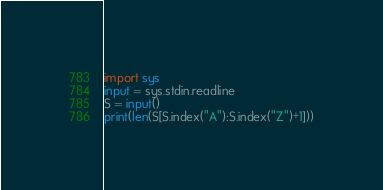<code> <loc_0><loc_0><loc_500><loc_500><_Python_>import sys
input = sys.stdin.readline
S = input()
print(len(S[S.index("A"):S.index("Z")+1]))</code> 